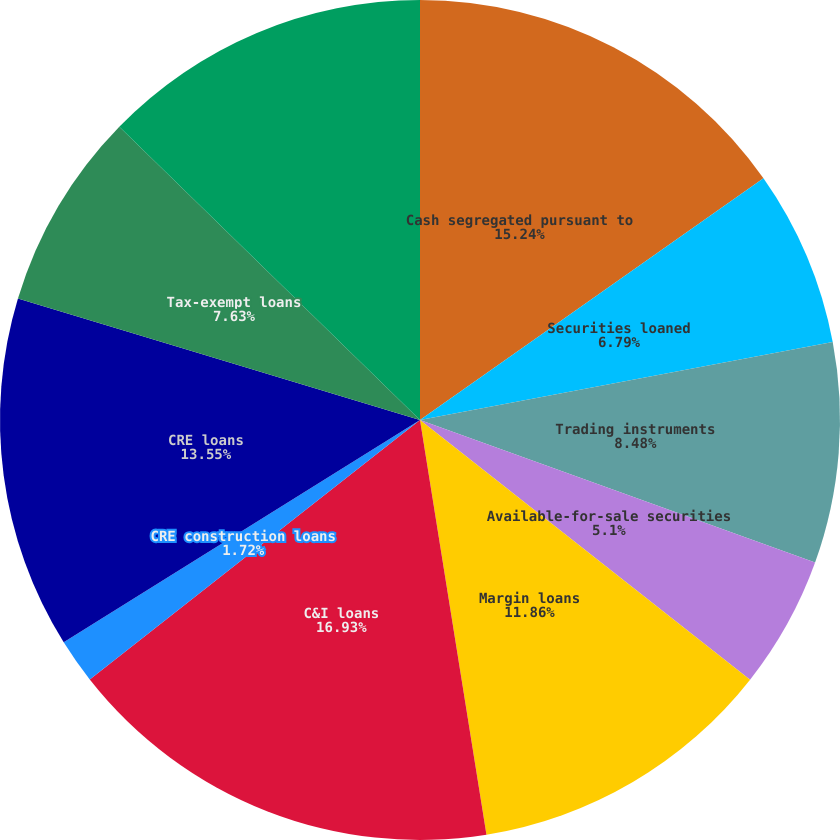<chart> <loc_0><loc_0><loc_500><loc_500><pie_chart><fcel>Cash segregated pursuant to<fcel>Securities loaned<fcel>Trading instruments<fcel>Available-for-sale securities<fcel>Margin loans<fcel>C&I loans<fcel>CRE construction loans<fcel>CRE loans<fcel>Tax-exempt loans<fcel>Residential mortgage loans<nl><fcel>15.24%<fcel>6.79%<fcel>8.48%<fcel>5.1%<fcel>11.86%<fcel>16.93%<fcel>1.72%<fcel>13.55%<fcel>7.63%<fcel>12.7%<nl></chart> 